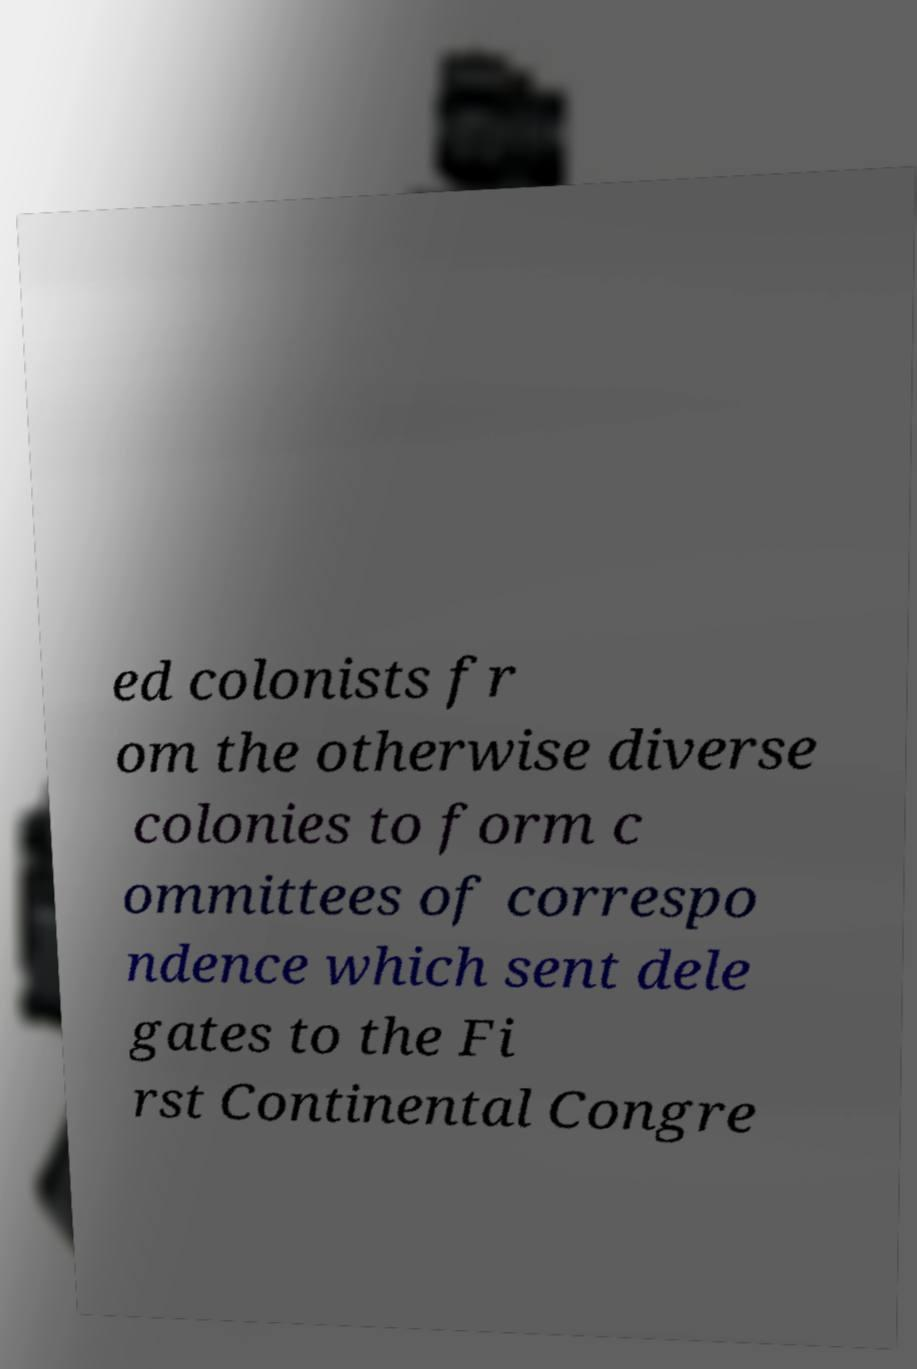Could you assist in decoding the text presented in this image and type it out clearly? ed colonists fr om the otherwise diverse colonies to form c ommittees of correspo ndence which sent dele gates to the Fi rst Continental Congre 